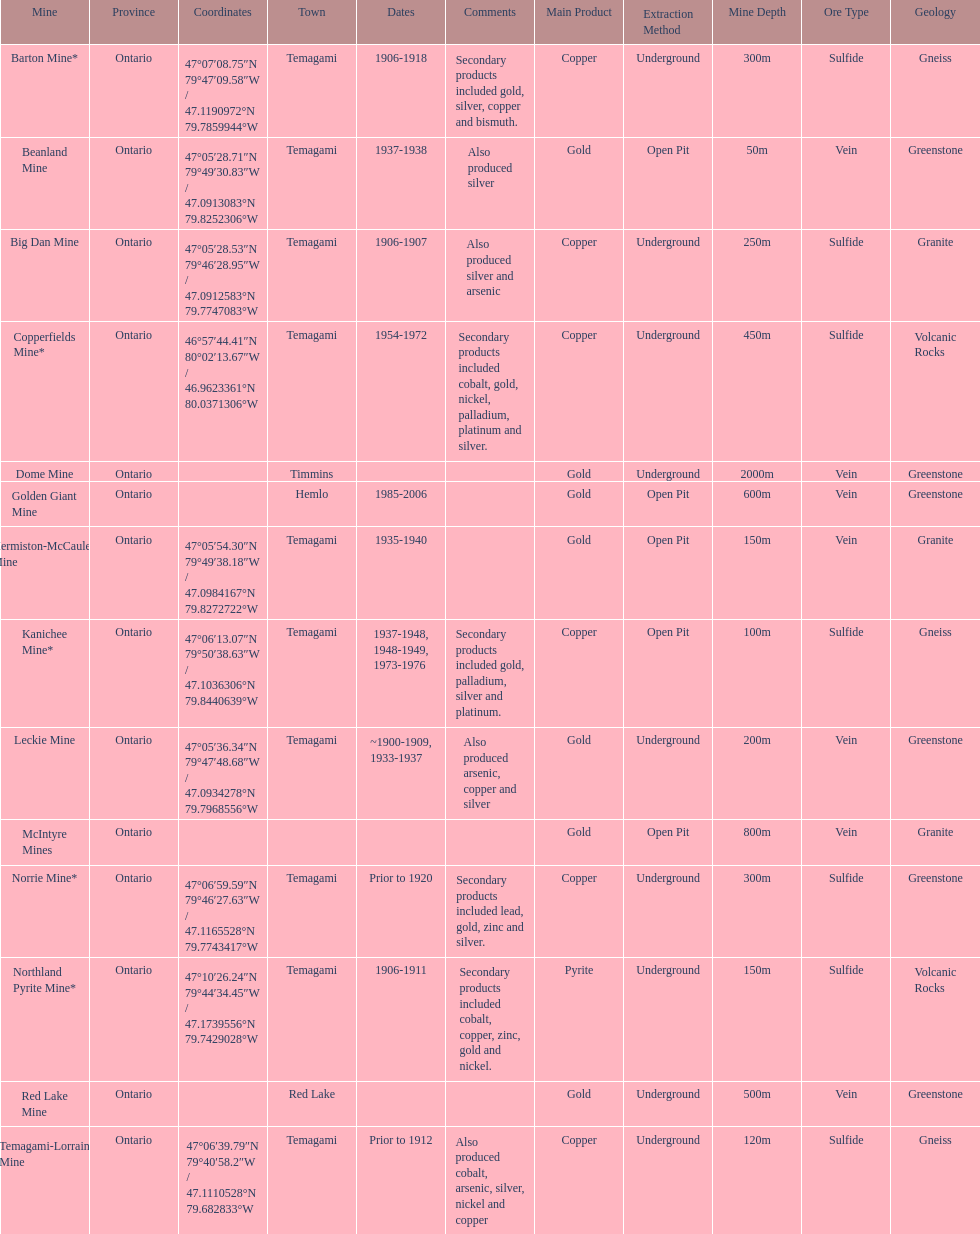Would you be able to parse every entry in this table? {'header': ['Mine', 'Province', 'Coordinates', 'Town', 'Dates', 'Comments', 'Main Product', 'Extraction Method', 'Mine Depth', 'Ore Type', 'Geology'], 'rows': [['Barton Mine*', 'Ontario', '47°07′08.75″N 79°47′09.58″W\ufeff / \ufeff47.1190972°N 79.7859944°W', 'Temagami', '1906-1918', 'Secondary products included gold, silver, copper and bismuth.', 'Copper', 'Underground', '300m', 'Sulfide', 'Gneiss'], ['Beanland Mine', 'Ontario', '47°05′28.71″N 79°49′30.83″W\ufeff / \ufeff47.0913083°N 79.8252306°W', 'Temagami', '1937-1938', 'Also produced silver', 'Gold', 'Open Pit', '50m', 'Vein', 'Greenstone'], ['Big Dan Mine', 'Ontario', '47°05′28.53″N 79°46′28.95″W\ufeff / \ufeff47.0912583°N 79.7747083°W', 'Temagami', '1906-1907', 'Also produced silver and arsenic', 'Copper', 'Underground', '250m', 'Sulfide', 'Granite'], ['Copperfields Mine*', 'Ontario', '46°57′44.41″N 80°02′13.67″W\ufeff / \ufeff46.9623361°N 80.0371306°W', 'Temagami', '1954-1972', 'Secondary products included cobalt, gold, nickel, palladium, platinum and silver.', 'Copper', 'Underground', '450m', 'Sulfide', 'Volcanic Rocks'], ['Dome Mine', 'Ontario', '', 'Timmins', '', '', 'Gold', 'Underground', '2000m', 'Vein', 'Greenstone'], ['Golden Giant Mine', 'Ontario', '', 'Hemlo', '1985-2006', '', 'Gold', 'Open Pit', '600m', 'Vein', 'Greenstone'], ['Hermiston-McCauley Mine', 'Ontario', '47°05′54.30″N 79°49′38.18″W\ufeff / \ufeff47.0984167°N 79.8272722°W', 'Temagami', '1935-1940', '', 'Gold', 'Open Pit', '150m', 'Vein', 'Granite'], ['Kanichee Mine*', 'Ontario', '47°06′13.07″N 79°50′38.63″W\ufeff / \ufeff47.1036306°N 79.8440639°W', 'Temagami', '1937-1948, 1948-1949, 1973-1976', 'Secondary products included gold, palladium, silver and platinum.', 'Copper', 'Open Pit', '100m', 'Sulfide', 'Gneiss'], ['Leckie Mine', 'Ontario', '47°05′36.34″N 79°47′48.68″W\ufeff / \ufeff47.0934278°N 79.7968556°W', 'Temagami', '~1900-1909, 1933-1937', 'Also produced arsenic, copper and silver', 'Gold', 'Underground', '200m', 'Vein', 'Greenstone'], ['McIntyre Mines', 'Ontario', '', '', '', '', 'Gold', 'Open Pit', '800m', 'Vein', 'Granite'], ['Norrie Mine*', 'Ontario', '47°06′59.59″N 79°46′27.63″W\ufeff / \ufeff47.1165528°N 79.7743417°W', 'Temagami', 'Prior to 1920', 'Secondary products included lead, gold, zinc and silver.', 'Copper', 'Underground', '300m', 'Sulfide', 'Greenstone'], ['Northland Pyrite Mine*', 'Ontario', '47°10′26.24″N 79°44′34.45″W\ufeff / \ufeff47.1739556°N 79.7429028°W', 'Temagami', '1906-1911', 'Secondary products included cobalt, copper, zinc, gold and nickel.', 'Pyrite', 'Underground', '150m', 'Sulfide', 'Volcanic Rocks'], ['Red Lake Mine', 'Ontario', '', 'Red Lake', '', '', 'Gold', 'Underground', '500m', 'Vein', 'Greenstone'], ['Temagami-Lorrain Mine', 'Ontario', '47°06′39.79″N 79°40′58.2″W\ufeff / \ufeff47.1110528°N 79.682833°W', 'Temagami', 'Prior to 1912', 'Also produced cobalt, arsenic, silver, nickel and copper', 'Copper', 'Underground', '120m', 'Sulfide', 'Gneiss']]} How many times is temagami listedon the list? 10. 